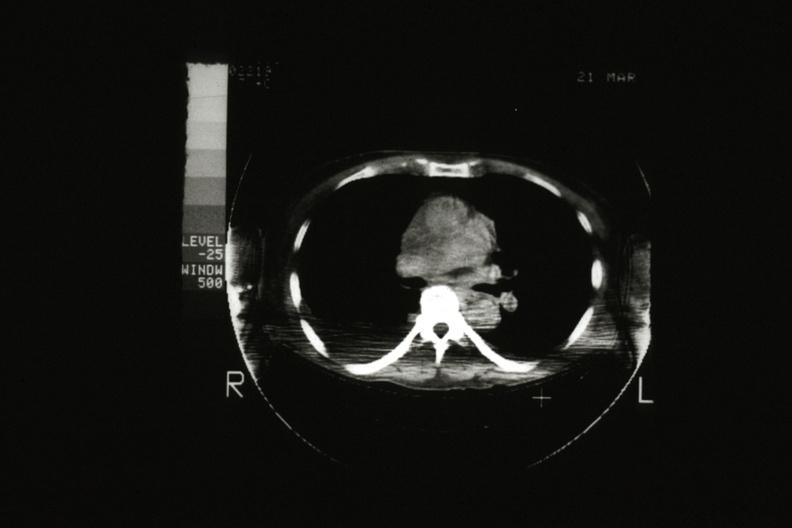s thymus present?
Answer the question using a single word or phrase. Yes 